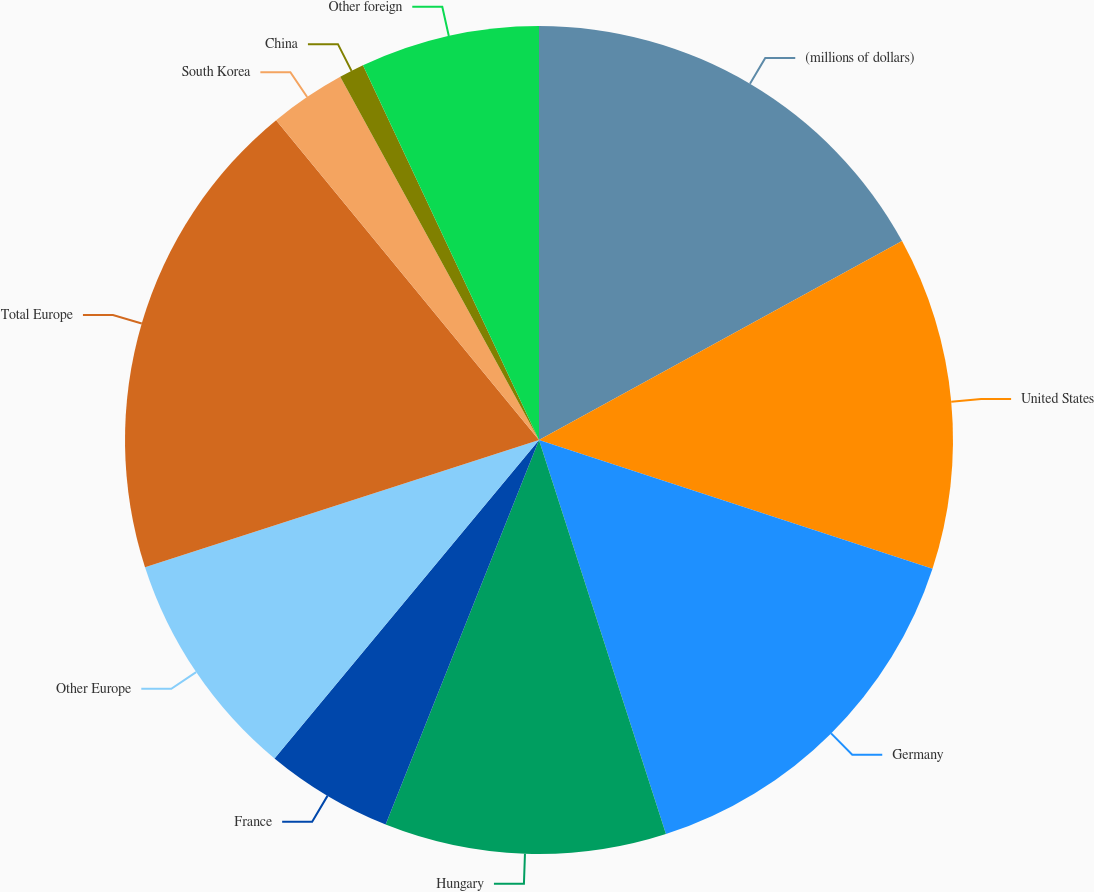Convert chart. <chart><loc_0><loc_0><loc_500><loc_500><pie_chart><fcel>(millions of dollars)<fcel>United States<fcel>Germany<fcel>Hungary<fcel>France<fcel>Other Europe<fcel>Total Europe<fcel>South Korea<fcel>China<fcel>Other foreign<nl><fcel>17.02%<fcel>13.01%<fcel>15.01%<fcel>11.0%<fcel>4.99%<fcel>9.0%<fcel>19.02%<fcel>2.98%<fcel>0.98%<fcel>6.99%<nl></chart> 